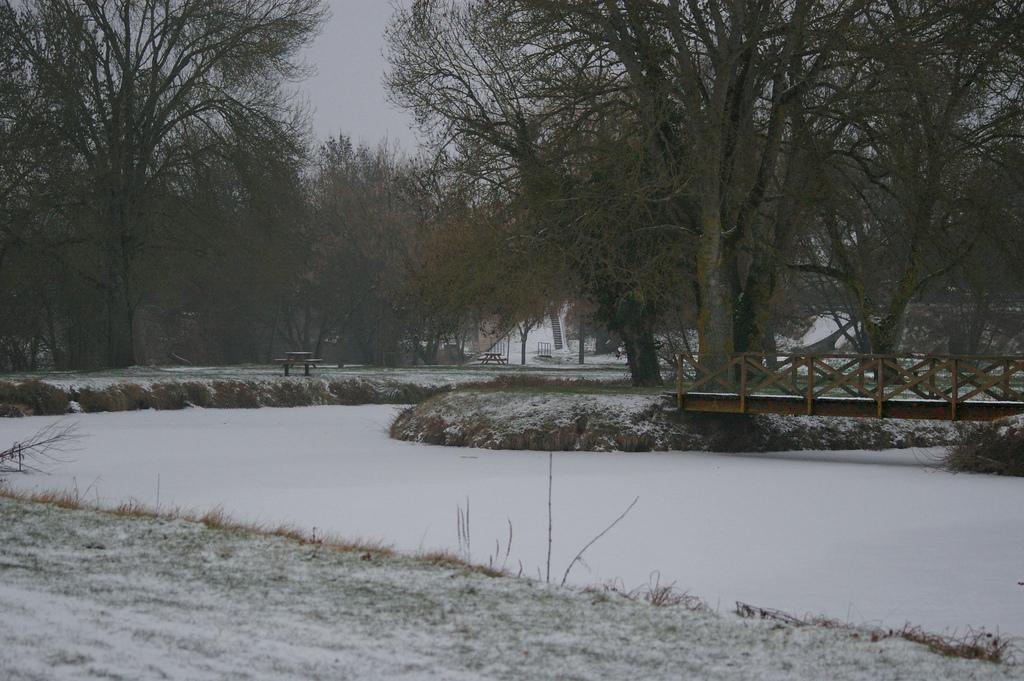Describe this image in one or two sentences. In the foreground of this image, there is land, snow, a bridge, trees, few benches and the sky. 